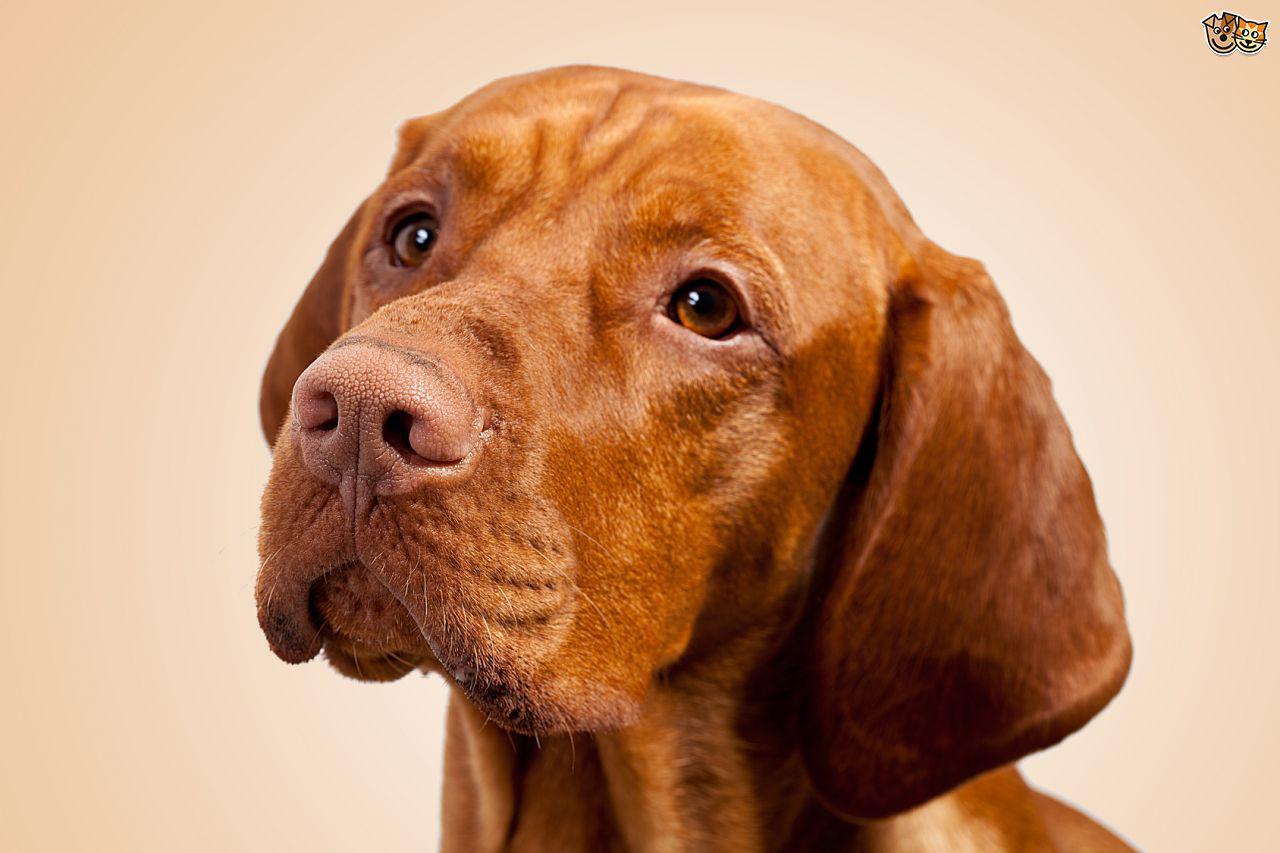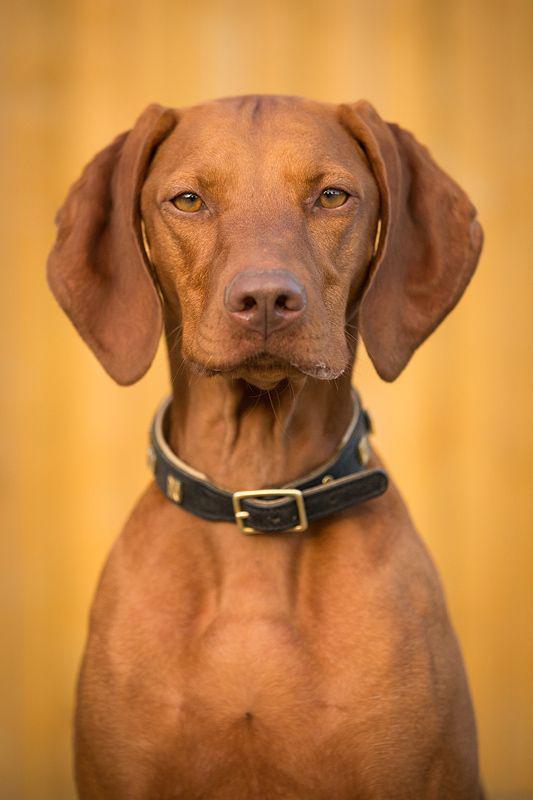The first image is the image on the left, the second image is the image on the right. Assess this claim about the two images: "Each image contains a single dog, and the left image features a dog with its head cocked, while the right image shows a dog looking directly forward with a straight head.". Correct or not? Answer yes or no. Yes. The first image is the image on the left, the second image is the image on the right. Assess this claim about the two images: "One dog is standing.". Correct or not? Answer yes or no. No. 